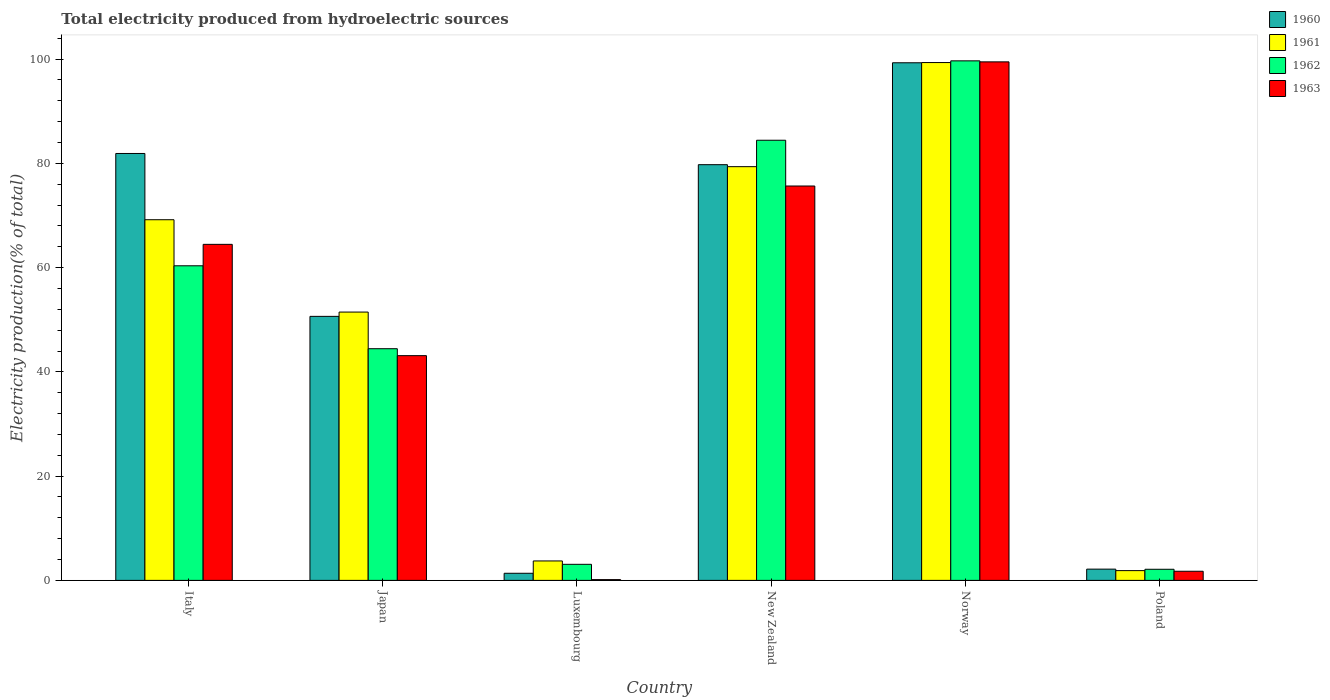How many different coloured bars are there?
Provide a succinct answer. 4. How many groups of bars are there?
Your response must be concise. 6. How many bars are there on the 6th tick from the right?
Your response must be concise. 4. What is the label of the 4th group of bars from the left?
Make the answer very short. New Zealand. What is the total electricity produced in 1960 in Poland?
Provide a succinct answer. 2.16. Across all countries, what is the maximum total electricity produced in 1960?
Provide a short and direct response. 99.3. Across all countries, what is the minimum total electricity produced in 1961?
Make the answer very short. 1.87. In which country was the total electricity produced in 1960 minimum?
Ensure brevity in your answer.  Luxembourg. What is the total total electricity produced in 1961 in the graph?
Offer a very short reply. 304.98. What is the difference between the total electricity produced in 1961 in Italy and that in Luxembourg?
Offer a terse response. 65.46. What is the difference between the total electricity produced in 1962 in Japan and the total electricity produced in 1960 in Italy?
Provide a succinct answer. -37.46. What is the average total electricity produced in 1960 per country?
Provide a succinct answer. 52.52. What is the difference between the total electricity produced of/in 1961 and total electricity produced of/in 1963 in Italy?
Your answer should be very brief. 4.72. What is the ratio of the total electricity produced in 1961 in Italy to that in Poland?
Make the answer very short. 36.93. Is the total electricity produced in 1963 in Norway less than that in Poland?
Ensure brevity in your answer.  No. What is the difference between the highest and the second highest total electricity produced in 1963?
Provide a short and direct response. -11.19. What is the difference between the highest and the lowest total electricity produced in 1962?
Ensure brevity in your answer.  97.54. In how many countries, is the total electricity produced in 1961 greater than the average total electricity produced in 1961 taken over all countries?
Make the answer very short. 4. Is the sum of the total electricity produced in 1962 in Luxembourg and Norway greater than the maximum total electricity produced in 1961 across all countries?
Provide a succinct answer. Yes. What does the 1st bar from the right in Italy represents?
Offer a very short reply. 1963. Is it the case that in every country, the sum of the total electricity produced in 1963 and total electricity produced in 1960 is greater than the total electricity produced in 1962?
Your answer should be very brief. No. What is the difference between two consecutive major ticks on the Y-axis?
Make the answer very short. 20. Are the values on the major ticks of Y-axis written in scientific E-notation?
Give a very brief answer. No. Does the graph contain grids?
Your answer should be compact. No. Where does the legend appear in the graph?
Ensure brevity in your answer.  Top right. How are the legend labels stacked?
Your response must be concise. Vertical. What is the title of the graph?
Offer a terse response. Total electricity produced from hydroelectric sources. Does "1973" appear as one of the legend labels in the graph?
Your answer should be compact. No. What is the label or title of the X-axis?
Provide a short and direct response. Country. What is the label or title of the Y-axis?
Your response must be concise. Electricity production(% of total). What is the Electricity production(% of total) in 1960 in Italy?
Your response must be concise. 81.9. What is the Electricity production(% of total) of 1961 in Italy?
Your answer should be very brief. 69.19. What is the Electricity production(% of total) of 1962 in Italy?
Keep it short and to the point. 60.35. What is the Electricity production(% of total) in 1963 in Italy?
Keep it short and to the point. 64.47. What is the Electricity production(% of total) of 1960 in Japan?
Your answer should be very brief. 50.65. What is the Electricity production(% of total) of 1961 in Japan?
Keep it short and to the point. 51.48. What is the Electricity production(% of total) in 1962 in Japan?
Give a very brief answer. 44.44. What is the Electricity production(% of total) of 1963 in Japan?
Your answer should be very brief. 43.11. What is the Electricity production(% of total) in 1960 in Luxembourg?
Offer a very short reply. 1.37. What is the Electricity production(% of total) of 1961 in Luxembourg?
Your response must be concise. 3.73. What is the Electricity production(% of total) in 1962 in Luxembourg?
Provide a short and direct response. 3.08. What is the Electricity production(% of total) of 1963 in Luxembourg?
Your response must be concise. 0.15. What is the Electricity production(% of total) in 1960 in New Zealand?
Offer a terse response. 79.75. What is the Electricity production(% of total) of 1961 in New Zealand?
Offer a very short reply. 79.37. What is the Electricity production(% of total) in 1962 in New Zealand?
Your answer should be very brief. 84.44. What is the Electricity production(% of total) in 1963 in New Zealand?
Keep it short and to the point. 75.66. What is the Electricity production(% of total) in 1960 in Norway?
Your response must be concise. 99.3. What is the Electricity production(% of total) in 1961 in Norway?
Make the answer very short. 99.34. What is the Electricity production(% of total) in 1962 in Norway?
Offer a very short reply. 99.67. What is the Electricity production(% of total) in 1963 in Norway?
Your answer should be compact. 99.47. What is the Electricity production(% of total) in 1960 in Poland?
Your answer should be compact. 2.16. What is the Electricity production(% of total) of 1961 in Poland?
Give a very brief answer. 1.87. What is the Electricity production(% of total) in 1962 in Poland?
Offer a very short reply. 2.13. What is the Electricity production(% of total) of 1963 in Poland?
Your response must be concise. 1.75. Across all countries, what is the maximum Electricity production(% of total) of 1960?
Offer a terse response. 99.3. Across all countries, what is the maximum Electricity production(% of total) in 1961?
Your answer should be very brief. 99.34. Across all countries, what is the maximum Electricity production(% of total) in 1962?
Provide a short and direct response. 99.67. Across all countries, what is the maximum Electricity production(% of total) of 1963?
Your response must be concise. 99.47. Across all countries, what is the minimum Electricity production(% of total) of 1960?
Keep it short and to the point. 1.37. Across all countries, what is the minimum Electricity production(% of total) in 1961?
Your answer should be very brief. 1.87. Across all countries, what is the minimum Electricity production(% of total) in 1962?
Ensure brevity in your answer.  2.13. Across all countries, what is the minimum Electricity production(% of total) of 1963?
Keep it short and to the point. 0.15. What is the total Electricity production(% of total) of 1960 in the graph?
Provide a short and direct response. 315.13. What is the total Electricity production(% of total) of 1961 in the graph?
Provide a short and direct response. 304.98. What is the total Electricity production(% of total) in 1962 in the graph?
Offer a very short reply. 294.12. What is the total Electricity production(% of total) in 1963 in the graph?
Give a very brief answer. 284.61. What is the difference between the Electricity production(% of total) in 1960 in Italy and that in Japan?
Give a very brief answer. 31.25. What is the difference between the Electricity production(% of total) of 1961 in Italy and that in Japan?
Your answer should be very brief. 17.71. What is the difference between the Electricity production(% of total) of 1962 in Italy and that in Japan?
Give a very brief answer. 15.91. What is the difference between the Electricity production(% of total) in 1963 in Italy and that in Japan?
Keep it short and to the point. 21.35. What is the difference between the Electricity production(% of total) in 1960 in Italy and that in Luxembourg?
Give a very brief answer. 80.53. What is the difference between the Electricity production(% of total) in 1961 in Italy and that in Luxembourg?
Make the answer very short. 65.46. What is the difference between the Electricity production(% of total) of 1962 in Italy and that in Luxembourg?
Ensure brevity in your answer.  57.27. What is the difference between the Electricity production(% of total) of 1963 in Italy and that in Luxembourg?
Ensure brevity in your answer.  64.32. What is the difference between the Electricity production(% of total) in 1960 in Italy and that in New Zealand?
Your answer should be very brief. 2.15. What is the difference between the Electricity production(% of total) in 1961 in Italy and that in New Zealand?
Give a very brief answer. -10.18. What is the difference between the Electricity production(% of total) in 1962 in Italy and that in New Zealand?
Keep it short and to the point. -24.08. What is the difference between the Electricity production(% of total) in 1963 in Italy and that in New Zealand?
Your response must be concise. -11.19. What is the difference between the Electricity production(% of total) of 1960 in Italy and that in Norway?
Give a very brief answer. -17.4. What is the difference between the Electricity production(% of total) in 1961 in Italy and that in Norway?
Give a very brief answer. -30.15. What is the difference between the Electricity production(% of total) in 1962 in Italy and that in Norway?
Give a very brief answer. -39.32. What is the difference between the Electricity production(% of total) of 1963 in Italy and that in Norway?
Your response must be concise. -35.01. What is the difference between the Electricity production(% of total) in 1960 in Italy and that in Poland?
Ensure brevity in your answer.  79.74. What is the difference between the Electricity production(% of total) in 1961 in Italy and that in Poland?
Your answer should be compact. 67.32. What is the difference between the Electricity production(% of total) of 1962 in Italy and that in Poland?
Provide a succinct answer. 58.22. What is the difference between the Electricity production(% of total) in 1963 in Italy and that in Poland?
Ensure brevity in your answer.  62.72. What is the difference between the Electricity production(% of total) of 1960 in Japan and that in Luxembourg?
Keep it short and to the point. 49.28. What is the difference between the Electricity production(% of total) of 1961 in Japan and that in Luxembourg?
Keep it short and to the point. 47.75. What is the difference between the Electricity production(% of total) of 1962 in Japan and that in Luxembourg?
Offer a very short reply. 41.36. What is the difference between the Electricity production(% of total) in 1963 in Japan and that in Luxembourg?
Give a very brief answer. 42.97. What is the difference between the Electricity production(% of total) of 1960 in Japan and that in New Zealand?
Your answer should be compact. -29.1. What is the difference between the Electricity production(% of total) in 1961 in Japan and that in New Zealand?
Offer a very short reply. -27.9. What is the difference between the Electricity production(% of total) of 1962 in Japan and that in New Zealand?
Your response must be concise. -39.99. What is the difference between the Electricity production(% of total) in 1963 in Japan and that in New Zealand?
Offer a very short reply. -32.54. What is the difference between the Electricity production(% of total) of 1960 in Japan and that in Norway?
Your response must be concise. -48.65. What is the difference between the Electricity production(% of total) in 1961 in Japan and that in Norway?
Ensure brevity in your answer.  -47.87. What is the difference between the Electricity production(% of total) of 1962 in Japan and that in Norway?
Offer a very short reply. -55.23. What is the difference between the Electricity production(% of total) of 1963 in Japan and that in Norway?
Give a very brief answer. -56.36. What is the difference between the Electricity production(% of total) of 1960 in Japan and that in Poland?
Your answer should be compact. 48.49. What is the difference between the Electricity production(% of total) of 1961 in Japan and that in Poland?
Provide a short and direct response. 49.6. What is the difference between the Electricity production(% of total) in 1962 in Japan and that in Poland?
Keep it short and to the point. 42.31. What is the difference between the Electricity production(% of total) in 1963 in Japan and that in Poland?
Offer a very short reply. 41.36. What is the difference between the Electricity production(% of total) in 1960 in Luxembourg and that in New Zealand?
Give a very brief answer. -78.38. What is the difference between the Electricity production(% of total) of 1961 in Luxembourg and that in New Zealand?
Give a very brief answer. -75.64. What is the difference between the Electricity production(% of total) of 1962 in Luxembourg and that in New Zealand?
Provide a succinct answer. -81.36. What is the difference between the Electricity production(% of total) in 1963 in Luxembourg and that in New Zealand?
Ensure brevity in your answer.  -75.51. What is the difference between the Electricity production(% of total) of 1960 in Luxembourg and that in Norway?
Offer a very short reply. -97.93. What is the difference between the Electricity production(% of total) of 1961 in Luxembourg and that in Norway?
Provide a short and direct response. -95.61. What is the difference between the Electricity production(% of total) of 1962 in Luxembourg and that in Norway?
Make the answer very short. -96.59. What is the difference between the Electricity production(% of total) in 1963 in Luxembourg and that in Norway?
Give a very brief answer. -99.33. What is the difference between the Electricity production(% of total) in 1960 in Luxembourg and that in Poland?
Keep it short and to the point. -0.79. What is the difference between the Electricity production(% of total) in 1961 in Luxembourg and that in Poland?
Ensure brevity in your answer.  1.86. What is the difference between the Electricity production(% of total) of 1962 in Luxembourg and that in Poland?
Your response must be concise. 0.95. What is the difference between the Electricity production(% of total) in 1963 in Luxembourg and that in Poland?
Ensure brevity in your answer.  -1.6. What is the difference between the Electricity production(% of total) in 1960 in New Zealand and that in Norway?
Offer a terse response. -19.55. What is the difference between the Electricity production(% of total) of 1961 in New Zealand and that in Norway?
Provide a succinct answer. -19.97. What is the difference between the Electricity production(% of total) in 1962 in New Zealand and that in Norway?
Provide a short and direct response. -15.23. What is the difference between the Electricity production(% of total) in 1963 in New Zealand and that in Norway?
Provide a short and direct response. -23.82. What is the difference between the Electricity production(% of total) in 1960 in New Zealand and that in Poland?
Keep it short and to the point. 77.59. What is the difference between the Electricity production(% of total) of 1961 in New Zealand and that in Poland?
Make the answer very short. 77.5. What is the difference between the Electricity production(% of total) in 1962 in New Zealand and that in Poland?
Make the answer very short. 82.31. What is the difference between the Electricity production(% of total) in 1963 in New Zealand and that in Poland?
Offer a very short reply. 73.91. What is the difference between the Electricity production(% of total) in 1960 in Norway and that in Poland?
Ensure brevity in your answer.  97.14. What is the difference between the Electricity production(% of total) of 1961 in Norway and that in Poland?
Your response must be concise. 97.47. What is the difference between the Electricity production(% of total) in 1962 in Norway and that in Poland?
Your answer should be compact. 97.54. What is the difference between the Electricity production(% of total) of 1963 in Norway and that in Poland?
Provide a short and direct response. 97.72. What is the difference between the Electricity production(% of total) of 1960 in Italy and the Electricity production(% of total) of 1961 in Japan?
Offer a very short reply. 30.42. What is the difference between the Electricity production(% of total) of 1960 in Italy and the Electricity production(% of total) of 1962 in Japan?
Ensure brevity in your answer.  37.46. What is the difference between the Electricity production(% of total) in 1960 in Italy and the Electricity production(% of total) in 1963 in Japan?
Provide a succinct answer. 38.79. What is the difference between the Electricity production(% of total) in 1961 in Italy and the Electricity production(% of total) in 1962 in Japan?
Provide a short and direct response. 24.75. What is the difference between the Electricity production(% of total) in 1961 in Italy and the Electricity production(% of total) in 1963 in Japan?
Give a very brief answer. 26.08. What is the difference between the Electricity production(% of total) in 1962 in Italy and the Electricity production(% of total) in 1963 in Japan?
Keep it short and to the point. 17.24. What is the difference between the Electricity production(% of total) in 1960 in Italy and the Electricity production(% of total) in 1961 in Luxembourg?
Provide a succinct answer. 78.17. What is the difference between the Electricity production(% of total) in 1960 in Italy and the Electricity production(% of total) in 1962 in Luxembourg?
Your answer should be very brief. 78.82. What is the difference between the Electricity production(% of total) in 1960 in Italy and the Electricity production(% of total) in 1963 in Luxembourg?
Offer a terse response. 81.75. What is the difference between the Electricity production(% of total) in 1961 in Italy and the Electricity production(% of total) in 1962 in Luxembourg?
Provide a succinct answer. 66.11. What is the difference between the Electricity production(% of total) of 1961 in Italy and the Electricity production(% of total) of 1963 in Luxembourg?
Your answer should be compact. 69.04. What is the difference between the Electricity production(% of total) of 1962 in Italy and the Electricity production(% of total) of 1963 in Luxembourg?
Provide a succinct answer. 60.21. What is the difference between the Electricity production(% of total) in 1960 in Italy and the Electricity production(% of total) in 1961 in New Zealand?
Your answer should be compact. 2.53. What is the difference between the Electricity production(% of total) in 1960 in Italy and the Electricity production(% of total) in 1962 in New Zealand?
Ensure brevity in your answer.  -2.54. What is the difference between the Electricity production(% of total) of 1960 in Italy and the Electricity production(% of total) of 1963 in New Zealand?
Offer a very short reply. 6.24. What is the difference between the Electricity production(% of total) in 1961 in Italy and the Electricity production(% of total) in 1962 in New Zealand?
Ensure brevity in your answer.  -15.25. What is the difference between the Electricity production(% of total) in 1961 in Italy and the Electricity production(% of total) in 1963 in New Zealand?
Offer a terse response. -6.47. What is the difference between the Electricity production(% of total) in 1962 in Italy and the Electricity production(% of total) in 1963 in New Zealand?
Provide a short and direct response. -15.3. What is the difference between the Electricity production(% of total) of 1960 in Italy and the Electricity production(% of total) of 1961 in Norway?
Your answer should be very brief. -17.44. What is the difference between the Electricity production(% of total) in 1960 in Italy and the Electricity production(% of total) in 1962 in Norway?
Provide a short and direct response. -17.77. What is the difference between the Electricity production(% of total) of 1960 in Italy and the Electricity production(% of total) of 1963 in Norway?
Make the answer very short. -17.57. What is the difference between the Electricity production(% of total) of 1961 in Italy and the Electricity production(% of total) of 1962 in Norway?
Provide a short and direct response. -30.48. What is the difference between the Electricity production(% of total) in 1961 in Italy and the Electricity production(% of total) in 1963 in Norway?
Provide a short and direct response. -30.28. What is the difference between the Electricity production(% of total) in 1962 in Italy and the Electricity production(% of total) in 1963 in Norway?
Make the answer very short. -39.12. What is the difference between the Electricity production(% of total) of 1960 in Italy and the Electricity production(% of total) of 1961 in Poland?
Offer a terse response. 80.03. What is the difference between the Electricity production(% of total) in 1960 in Italy and the Electricity production(% of total) in 1962 in Poland?
Your response must be concise. 79.77. What is the difference between the Electricity production(% of total) in 1960 in Italy and the Electricity production(% of total) in 1963 in Poland?
Your response must be concise. 80.15. What is the difference between the Electricity production(% of total) of 1961 in Italy and the Electricity production(% of total) of 1962 in Poland?
Your answer should be very brief. 67.06. What is the difference between the Electricity production(% of total) in 1961 in Italy and the Electricity production(% of total) in 1963 in Poland?
Make the answer very short. 67.44. What is the difference between the Electricity production(% of total) of 1962 in Italy and the Electricity production(% of total) of 1963 in Poland?
Offer a very short reply. 58.6. What is the difference between the Electricity production(% of total) of 1960 in Japan and the Electricity production(% of total) of 1961 in Luxembourg?
Ensure brevity in your answer.  46.92. What is the difference between the Electricity production(% of total) in 1960 in Japan and the Electricity production(% of total) in 1962 in Luxembourg?
Your answer should be compact. 47.57. What is the difference between the Electricity production(% of total) of 1960 in Japan and the Electricity production(% of total) of 1963 in Luxembourg?
Offer a terse response. 50.5. What is the difference between the Electricity production(% of total) of 1961 in Japan and the Electricity production(% of total) of 1962 in Luxembourg?
Provide a short and direct response. 48.39. What is the difference between the Electricity production(% of total) in 1961 in Japan and the Electricity production(% of total) in 1963 in Luxembourg?
Provide a short and direct response. 51.33. What is the difference between the Electricity production(% of total) in 1962 in Japan and the Electricity production(% of total) in 1963 in Luxembourg?
Keep it short and to the point. 44.3. What is the difference between the Electricity production(% of total) of 1960 in Japan and the Electricity production(% of total) of 1961 in New Zealand?
Offer a terse response. -28.72. What is the difference between the Electricity production(% of total) in 1960 in Japan and the Electricity production(% of total) in 1962 in New Zealand?
Ensure brevity in your answer.  -33.79. What is the difference between the Electricity production(% of total) in 1960 in Japan and the Electricity production(% of total) in 1963 in New Zealand?
Your answer should be very brief. -25.01. What is the difference between the Electricity production(% of total) of 1961 in Japan and the Electricity production(% of total) of 1962 in New Zealand?
Your response must be concise. -32.96. What is the difference between the Electricity production(% of total) of 1961 in Japan and the Electricity production(% of total) of 1963 in New Zealand?
Your response must be concise. -24.18. What is the difference between the Electricity production(% of total) of 1962 in Japan and the Electricity production(% of total) of 1963 in New Zealand?
Your answer should be compact. -31.21. What is the difference between the Electricity production(% of total) in 1960 in Japan and the Electricity production(% of total) in 1961 in Norway?
Offer a terse response. -48.69. What is the difference between the Electricity production(% of total) of 1960 in Japan and the Electricity production(% of total) of 1962 in Norway?
Provide a succinct answer. -49.02. What is the difference between the Electricity production(% of total) of 1960 in Japan and the Electricity production(% of total) of 1963 in Norway?
Offer a terse response. -48.83. What is the difference between the Electricity production(% of total) of 1961 in Japan and the Electricity production(% of total) of 1962 in Norway?
Ensure brevity in your answer.  -48.19. What is the difference between the Electricity production(% of total) of 1961 in Japan and the Electricity production(% of total) of 1963 in Norway?
Provide a short and direct response. -48. What is the difference between the Electricity production(% of total) in 1962 in Japan and the Electricity production(% of total) in 1963 in Norway?
Ensure brevity in your answer.  -55.03. What is the difference between the Electricity production(% of total) in 1960 in Japan and the Electricity production(% of total) in 1961 in Poland?
Provide a succinct answer. 48.78. What is the difference between the Electricity production(% of total) of 1960 in Japan and the Electricity production(% of total) of 1962 in Poland?
Your answer should be very brief. 48.52. What is the difference between the Electricity production(% of total) in 1960 in Japan and the Electricity production(% of total) in 1963 in Poland?
Make the answer very short. 48.9. What is the difference between the Electricity production(% of total) of 1961 in Japan and the Electricity production(% of total) of 1962 in Poland?
Make the answer very short. 49.34. What is the difference between the Electricity production(% of total) of 1961 in Japan and the Electricity production(% of total) of 1963 in Poland?
Your answer should be very brief. 49.72. What is the difference between the Electricity production(% of total) in 1962 in Japan and the Electricity production(% of total) in 1963 in Poland?
Make the answer very short. 42.69. What is the difference between the Electricity production(% of total) in 1960 in Luxembourg and the Electricity production(% of total) in 1961 in New Zealand?
Your answer should be compact. -78.01. What is the difference between the Electricity production(% of total) in 1960 in Luxembourg and the Electricity production(% of total) in 1962 in New Zealand?
Your answer should be compact. -83.07. What is the difference between the Electricity production(% of total) of 1960 in Luxembourg and the Electricity production(% of total) of 1963 in New Zealand?
Your answer should be very brief. -74.29. What is the difference between the Electricity production(% of total) of 1961 in Luxembourg and the Electricity production(% of total) of 1962 in New Zealand?
Provide a short and direct response. -80.71. What is the difference between the Electricity production(% of total) of 1961 in Luxembourg and the Electricity production(% of total) of 1963 in New Zealand?
Ensure brevity in your answer.  -71.93. What is the difference between the Electricity production(% of total) in 1962 in Luxembourg and the Electricity production(% of total) in 1963 in New Zealand?
Give a very brief answer. -72.58. What is the difference between the Electricity production(% of total) of 1960 in Luxembourg and the Electricity production(% of total) of 1961 in Norway?
Your answer should be compact. -97.98. What is the difference between the Electricity production(% of total) of 1960 in Luxembourg and the Electricity production(% of total) of 1962 in Norway?
Offer a terse response. -98.3. What is the difference between the Electricity production(% of total) in 1960 in Luxembourg and the Electricity production(% of total) in 1963 in Norway?
Provide a short and direct response. -98.11. What is the difference between the Electricity production(% of total) in 1961 in Luxembourg and the Electricity production(% of total) in 1962 in Norway?
Provide a short and direct response. -95.94. What is the difference between the Electricity production(% of total) in 1961 in Luxembourg and the Electricity production(% of total) in 1963 in Norway?
Your answer should be compact. -95.74. What is the difference between the Electricity production(% of total) of 1962 in Luxembourg and the Electricity production(% of total) of 1963 in Norway?
Your response must be concise. -96.39. What is the difference between the Electricity production(% of total) in 1960 in Luxembourg and the Electricity production(% of total) in 1961 in Poland?
Offer a very short reply. -0.51. What is the difference between the Electricity production(% of total) of 1960 in Luxembourg and the Electricity production(% of total) of 1962 in Poland?
Your response must be concise. -0.77. What is the difference between the Electricity production(% of total) in 1960 in Luxembourg and the Electricity production(% of total) in 1963 in Poland?
Provide a short and direct response. -0.39. What is the difference between the Electricity production(% of total) of 1961 in Luxembourg and the Electricity production(% of total) of 1962 in Poland?
Give a very brief answer. 1.6. What is the difference between the Electricity production(% of total) of 1961 in Luxembourg and the Electricity production(% of total) of 1963 in Poland?
Make the answer very short. 1.98. What is the difference between the Electricity production(% of total) of 1962 in Luxembourg and the Electricity production(% of total) of 1963 in Poland?
Give a very brief answer. 1.33. What is the difference between the Electricity production(% of total) of 1960 in New Zealand and the Electricity production(% of total) of 1961 in Norway?
Give a very brief answer. -19.59. What is the difference between the Electricity production(% of total) in 1960 in New Zealand and the Electricity production(% of total) in 1962 in Norway?
Your answer should be very brief. -19.92. What is the difference between the Electricity production(% of total) in 1960 in New Zealand and the Electricity production(% of total) in 1963 in Norway?
Make the answer very short. -19.72. What is the difference between the Electricity production(% of total) of 1961 in New Zealand and the Electricity production(% of total) of 1962 in Norway?
Your answer should be very brief. -20.3. What is the difference between the Electricity production(% of total) of 1961 in New Zealand and the Electricity production(% of total) of 1963 in Norway?
Provide a short and direct response. -20.1. What is the difference between the Electricity production(% of total) in 1962 in New Zealand and the Electricity production(% of total) in 1963 in Norway?
Your answer should be very brief. -15.04. What is the difference between the Electricity production(% of total) in 1960 in New Zealand and the Electricity production(% of total) in 1961 in Poland?
Your response must be concise. 77.88. What is the difference between the Electricity production(% of total) of 1960 in New Zealand and the Electricity production(% of total) of 1962 in Poland?
Provide a succinct answer. 77.62. What is the difference between the Electricity production(% of total) of 1960 in New Zealand and the Electricity production(% of total) of 1963 in Poland?
Make the answer very short. 78. What is the difference between the Electricity production(% of total) of 1961 in New Zealand and the Electricity production(% of total) of 1962 in Poland?
Offer a terse response. 77.24. What is the difference between the Electricity production(% of total) in 1961 in New Zealand and the Electricity production(% of total) in 1963 in Poland?
Give a very brief answer. 77.62. What is the difference between the Electricity production(% of total) of 1962 in New Zealand and the Electricity production(% of total) of 1963 in Poland?
Your response must be concise. 82.69. What is the difference between the Electricity production(% of total) of 1960 in Norway and the Electricity production(% of total) of 1961 in Poland?
Provide a succinct answer. 97.43. What is the difference between the Electricity production(% of total) of 1960 in Norway and the Electricity production(% of total) of 1962 in Poland?
Ensure brevity in your answer.  97.17. What is the difference between the Electricity production(% of total) in 1960 in Norway and the Electricity production(% of total) in 1963 in Poland?
Make the answer very short. 97.55. What is the difference between the Electricity production(% of total) of 1961 in Norway and the Electricity production(% of total) of 1962 in Poland?
Your answer should be compact. 97.21. What is the difference between the Electricity production(% of total) of 1961 in Norway and the Electricity production(% of total) of 1963 in Poland?
Offer a very short reply. 97.59. What is the difference between the Electricity production(% of total) of 1962 in Norway and the Electricity production(% of total) of 1963 in Poland?
Offer a very short reply. 97.92. What is the average Electricity production(% of total) in 1960 per country?
Offer a very short reply. 52.52. What is the average Electricity production(% of total) of 1961 per country?
Make the answer very short. 50.83. What is the average Electricity production(% of total) in 1962 per country?
Provide a short and direct response. 49.02. What is the average Electricity production(% of total) in 1963 per country?
Offer a very short reply. 47.44. What is the difference between the Electricity production(% of total) in 1960 and Electricity production(% of total) in 1961 in Italy?
Provide a short and direct response. 12.71. What is the difference between the Electricity production(% of total) of 1960 and Electricity production(% of total) of 1962 in Italy?
Offer a very short reply. 21.55. What is the difference between the Electricity production(% of total) in 1960 and Electricity production(% of total) in 1963 in Italy?
Provide a succinct answer. 17.43. What is the difference between the Electricity production(% of total) of 1961 and Electricity production(% of total) of 1962 in Italy?
Keep it short and to the point. 8.84. What is the difference between the Electricity production(% of total) of 1961 and Electricity production(% of total) of 1963 in Italy?
Ensure brevity in your answer.  4.72. What is the difference between the Electricity production(% of total) of 1962 and Electricity production(% of total) of 1963 in Italy?
Offer a terse response. -4.11. What is the difference between the Electricity production(% of total) of 1960 and Electricity production(% of total) of 1961 in Japan?
Offer a terse response. -0.83. What is the difference between the Electricity production(% of total) in 1960 and Electricity production(% of total) in 1962 in Japan?
Your answer should be compact. 6.2. What is the difference between the Electricity production(% of total) of 1960 and Electricity production(% of total) of 1963 in Japan?
Give a very brief answer. 7.54. What is the difference between the Electricity production(% of total) of 1961 and Electricity production(% of total) of 1962 in Japan?
Keep it short and to the point. 7.03. What is the difference between the Electricity production(% of total) in 1961 and Electricity production(% of total) in 1963 in Japan?
Offer a very short reply. 8.36. What is the difference between the Electricity production(% of total) of 1962 and Electricity production(% of total) of 1963 in Japan?
Ensure brevity in your answer.  1.33. What is the difference between the Electricity production(% of total) in 1960 and Electricity production(% of total) in 1961 in Luxembourg?
Your response must be concise. -2.36. What is the difference between the Electricity production(% of total) of 1960 and Electricity production(% of total) of 1962 in Luxembourg?
Your response must be concise. -1.72. What is the difference between the Electricity production(% of total) of 1960 and Electricity production(% of total) of 1963 in Luxembourg?
Keep it short and to the point. 1.22. What is the difference between the Electricity production(% of total) in 1961 and Electricity production(% of total) in 1962 in Luxembourg?
Ensure brevity in your answer.  0.65. What is the difference between the Electricity production(% of total) in 1961 and Electricity production(% of total) in 1963 in Luxembourg?
Provide a succinct answer. 3.58. What is the difference between the Electricity production(% of total) of 1962 and Electricity production(% of total) of 1963 in Luxembourg?
Your answer should be compact. 2.93. What is the difference between the Electricity production(% of total) of 1960 and Electricity production(% of total) of 1961 in New Zealand?
Offer a very short reply. 0.38. What is the difference between the Electricity production(% of total) in 1960 and Electricity production(% of total) in 1962 in New Zealand?
Offer a very short reply. -4.69. What is the difference between the Electricity production(% of total) of 1960 and Electricity production(% of total) of 1963 in New Zealand?
Provide a short and direct response. 4.09. What is the difference between the Electricity production(% of total) in 1961 and Electricity production(% of total) in 1962 in New Zealand?
Offer a very short reply. -5.07. What is the difference between the Electricity production(% of total) of 1961 and Electricity production(% of total) of 1963 in New Zealand?
Ensure brevity in your answer.  3.71. What is the difference between the Electricity production(% of total) of 1962 and Electricity production(% of total) of 1963 in New Zealand?
Your response must be concise. 8.78. What is the difference between the Electricity production(% of total) in 1960 and Electricity production(% of total) in 1961 in Norway?
Give a very brief answer. -0.04. What is the difference between the Electricity production(% of total) of 1960 and Electricity production(% of total) of 1962 in Norway?
Your answer should be compact. -0.37. What is the difference between the Electricity production(% of total) of 1960 and Electricity production(% of total) of 1963 in Norway?
Provide a succinct answer. -0.17. What is the difference between the Electricity production(% of total) of 1961 and Electricity production(% of total) of 1962 in Norway?
Ensure brevity in your answer.  -0.33. What is the difference between the Electricity production(% of total) of 1961 and Electricity production(% of total) of 1963 in Norway?
Your answer should be very brief. -0.13. What is the difference between the Electricity production(% of total) of 1962 and Electricity production(% of total) of 1963 in Norway?
Provide a succinct answer. 0.19. What is the difference between the Electricity production(% of total) in 1960 and Electricity production(% of total) in 1961 in Poland?
Offer a very short reply. 0.28. What is the difference between the Electricity production(% of total) in 1960 and Electricity production(% of total) in 1962 in Poland?
Keep it short and to the point. 0.03. What is the difference between the Electricity production(% of total) of 1960 and Electricity production(% of total) of 1963 in Poland?
Make the answer very short. 0.41. What is the difference between the Electricity production(% of total) in 1961 and Electricity production(% of total) in 1962 in Poland?
Offer a terse response. -0.26. What is the difference between the Electricity production(% of total) in 1961 and Electricity production(% of total) in 1963 in Poland?
Ensure brevity in your answer.  0.12. What is the difference between the Electricity production(% of total) in 1962 and Electricity production(% of total) in 1963 in Poland?
Keep it short and to the point. 0.38. What is the ratio of the Electricity production(% of total) of 1960 in Italy to that in Japan?
Offer a very short reply. 1.62. What is the ratio of the Electricity production(% of total) of 1961 in Italy to that in Japan?
Provide a short and direct response. 1.34. What is the ratio of the Electricity production(% of total) in 1962 in Italy to that in Japan?
Provide a short and direct response. 1.36. What is the ratio of the Electricity production(% of total) in 1963 in Italy to that in Japan?
Your response must be concise. 1.5. What is the ratio of the Electricity production(% of total) in 1960 in Italy to that in Luxembourg?
Your answer should be very brief. 59.95. What is the ratio of the Electricity production(% of total) of 1961 in Italy to that in Luxembourg?
Offer a very short reply. 18.55. What is the ratio of the Electricity production(% of total) in 1962 in Italy to that in Luxembourg?
Give a very brief answer. 19.58. What is the ratio of the Electricity production(% of total) in 1963 in Italy to that in Luxembourg?
Make the answer very short. 436.77. What is the ratio of the Electricity production(% of total) in 1961 in Italy to that in New Zealand?
Your response must be concise. 0.87. What is the ratio of the Electricity production(% of total) in 1962 in Italy to that in New Zealand?
Offer a terse response. 0.71. What is the ratio of the Electricity production(% of total) of 1963 in Italy to that in New Zealand?
Offer a very short reply. 0.85. What is the ratio of the Electricity production(% of total) of 1960 in Italy to that in Norway?
Your answer should be compact. 0.82. What is the ratio of the Electricity production(% of total) in 1961 in Italy to that in Norway?
Keep it short and to the point. 0.7. What is the ratio of the Electricity production(% of total) in 1962 in Italy to that in Norway?
Offer a very short reply. 0.61. What is the ratio of the Electricity production(% of total) of 1963 in Italy to that in Norway?
Offer a terse response. 0.65. What is the ratio of the Electricity production(% of total) of 1960 in Italy to that in Poland?
Provide a short and direct response. 37.95. What is the ratio of the Electricity production(% of total) in 1961 in Italy to that in Poland?
Provide a short and direct response. 36.93. What is the ratio of the Electricity production(% of total) of 1962 in Italy to that in Poland?
Provide a short and direct response. 28.31. What is the ratio of the Electricity production(% of total) in 1963 in Italy to that in Poland?
Your answer should be very brief. 36.81. What is the ratio of the Electricity production(% of total) of 1960 in Japan to that in Luxembourg?
Make the answer very short. 37.08. What is the ratio of the Electricity production(% of total) in 1961 in Japan to that in Luxembourg?
Ensure brevity in your answer.  13.8. What is the ratio of the Electricity production(% of total) in 1962 in Japan to that in Luxembourg?
Offer a very short reply. 14.42. What is the ratio of the Electricity production(% of total) of 1963 in Japan to that in Luxembourg?
Offer a terse response. 292.1. What is the ratio of the Electricity production(% of total) in 1960 in Japan to that in New Zealand?
Give a very brief answer. 0.64. What is the ratio of the Electricity production(% of total) of 1961 in Japan to that in New Zealand?
Your response must be concise. 0.65. What is the ratio of the Electricity production(% of total) in 1962 in Japan to that in New Zealand?
Your answer should be compact. 0.53. What is the ratio of the Electricity production(% of total) in 1963 in Japan to that in New Zealand?
Provide a short and direct response. 0.57. What is the ratio of the Electricity production(% of total) in 1960 in Japan to that in Norway?
Your answer should be very brief. 0.51. What is the ratio of the Electricity production(% of total) in 1961 in Japan to that in Norway?
Keep it short and to the point. 0.52. What is the ratio of the Electricity production(% of total) in 1962 in Japan to that in Norway?
Your response must be concise. 0.45. What is the ratio of the Electricity production(% of total) of 1963 in Japan to that in Norway?
Ensure brevity in your answer.  0.43. What is the ratio of the Electricity production(% of total) of 1960 in Japan to that in Poland?
Offer a terse response. 23.47. What is the ratio of the Electricity production(% of total) in 1961 in Japan to that in Poland?
Ensure brevity in your answer.  27.48. What is the ratio of the Electricity production(% of total) in 1962 in Japan to that in Poland?
Offer a very short reply. 20.85. What is the ratio of the Electricity production(% of total) in 1963 in Japan to that in Poland?
Provide a succinct answer. 24.62. What is the ratio of the Electricity production(% of total) of 1960 in Luxembourg to that in New Zealand?
Provide a succinct answer. 0.02. What is the ratio of the Electricity production(% of total) of 1961 in Luxembourg to that in New Zealand?
Offer a very short reply. 0.05. What is the ratio of the Electricity production(% of total) of 1962 in Luxembourg to that in New Zealand?
Your response must be concise. 0.04. What is the ratio of the Electricity production(% of total) of 1963 in Luxembourg to that in New Zealand?
Your answer should be compact. 0. What is the ratio of the Electricity production(% of total) in 1960 in Luxembourg to that in Norway?
Provide a succinct answer. 0.01. What is the ratio of the Electricity production(% of total) in 1961 in Luxembourg to that in Norway?
Provide a short and direct response. 0.04. What is the ratio of the Electricity production(% of total) of 1962 in Luxembourg to that in Norway?
Your answer should be very brief. 0.03. What is the ratio of the Electricity production(% of total) in 1963 in Luxembourg to that in Norway?
Provide a short and direct response. 0. What is the ratio of the Electricity production(% of total) of 1960 in Luxembourg to that in Poland?
Your answer should be very brief. 0.63. What is the ratio of the Electricity production(% of total) in 1961 in Luxembourg to that in Poland?
Give a very brief answer. 1.99. What is the ratio of the Electricity production(% of total) in 1962 in Luxembourg to that in Poland?
Your answer should be compact. 1.45. What is the ratio of the Electricity production(% of total) in 1963 in Luxembourg to that in Poland?
Keep it short and to the point. 0.08. What is the ratio of the Electricity production(% of total) in 1960 in New Zealand to that in Norway?
Your response must be concise. 0.8. What is the ratio of the Electricity production(% of total) of 1961 in New Zealand to that in Norway?
Provide a succinct answer. 0.8. What is the ratio of the Electricity production(% of total) in 1962 in New Zealand to that in Norway?
Offer a terse response. 0.85. What is the ratio of the Electricity production(% of total) of 1963 in New Zealand to that in Norway?
Offer a terse response. 0.76. What is the ratio of the Electricity production(% of total) in 1960 in New Zealand to that in Poland?
Offer a very short reply. 36.95. What is the ratio of the Electricity production(% of total) in 1961 in New Zealand to that in Poland?
Provide a short and direct response. 42.37. What is the ratio of the Electricity production(% of total) of 1962 in New Zealand to that in Poland?
Your answer should be compact. 39.6. What is the ratio of the Electricity production(% of total) in 1963 in New Zealand to that in Poland?
Ensure brevity in your answer.  43.2. What is the ratio of the Electricity production(% of total) of 1960 in Norway to that in Poland?
Your answer should be very brief. 46.01. What is the ratio of the Electricity production(% of total) in 1961 in Norway to that in Poland?
Offer a very short reply. 53.03. What is the ratio of the Electricity production(% of total) of 1962 in Norway to that in Poland?
Keep it short and to the point. 46.75. What is the ratio of the Electricity production(% of total) of 1963 in Norway to that in Poland?
Offer a terse response. 56.8. What is the difference between the highest and the second highest Electricity production(% of total) in 1961?
Your answer should be compact. 19.97. What is the difference between the highest and the second highest Electricity production(% of total) in 1962?
Provide a succinct answer. 15.23. What is the difference between the highest and the second highest Electricity production(% of total) in 1963?
Your answer should be compact. 23.82. What is the difference between the highest and the lowest Electricity production(% of total) of 1960?
Offer a very short reply. 97.93. What is the difference between the highest and the lowest Electricity production(% of total) of 1961?
Provide a short and direct response. 97.47. What is the difference between the highest and the lowest Electricity production(% of total) of 1962?
Your answer should be compact. 97.54. What is the difference between the highest and the lowest Electricity production(% of total) of 1963?
Offer a terse response. 99.33. 